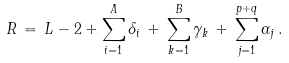Convert formula to latex. <formula><loc_0><loc_0><loc_500><loc_500>R \, = \, L - 2 + \sum _ { i = 1 } ^ { A } \delta _ { i } \, + \, \sum _ { k = 1 } ^ { B } \gamma _ { k } \, + \, \sum _ { j = 1 } ^ { p + q } \alpha _ { j } \, .</formula> 